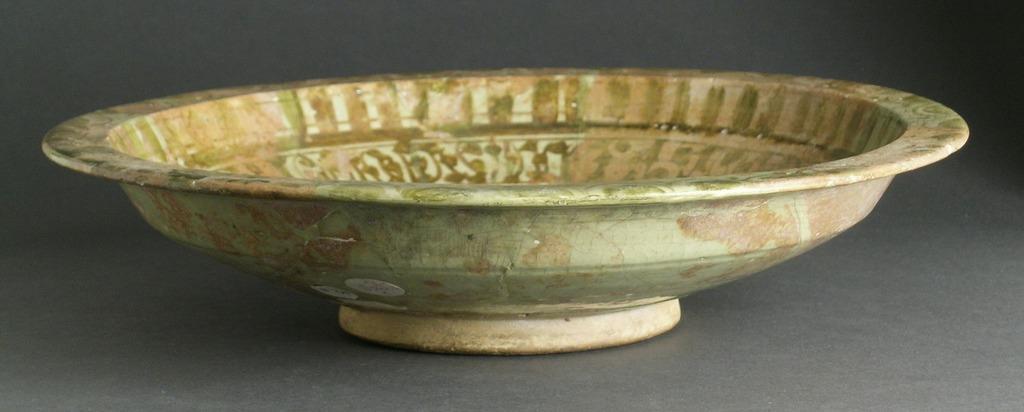Please provide a concise description of this image. Here in this picture we can see a ceramic dish present over there. 